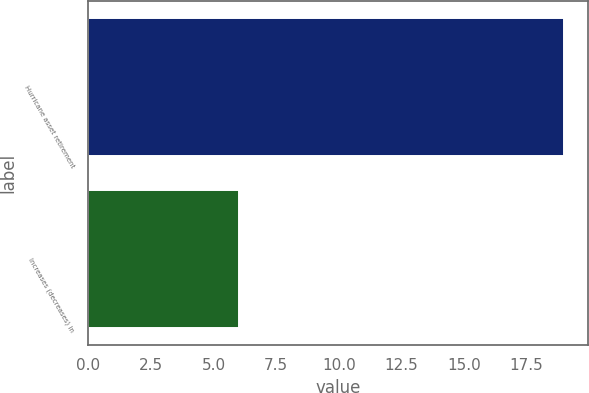Convert chart. <chart><loc_0><loc_0><loc_500><loc_500><bar_chart><fcel>Hurricane asset retirement<fcel>Increases (decreases) in<nl><fcel>19<fcel>6<nl></chart> 